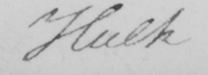Please transcribe the handwritten text in this image. Hulk 